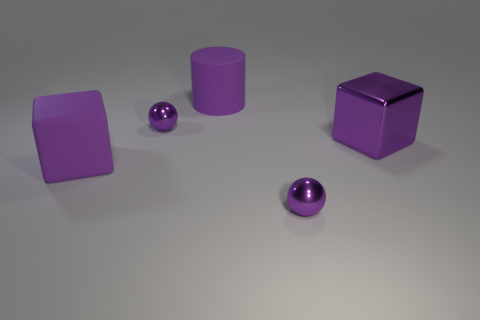Add 2 metal balls. How many objects exist? 7 Subtract all blocks. How many objects are left? 3 Subtract 2 blocks. How many blocks are left? 0 Subtract all yellow spheres. Subtract all yellow blocks. How many spheres are left? 2 Add 3 small purple things. How many small purple things are left? 5 Add 5 purple blocks. How many purple blocks exist? 7 Subtract 0 red cylinders. How many objects are left? 5 Subtract all blue rubber things. Subtract all big blocks. How many objects are left? 3 